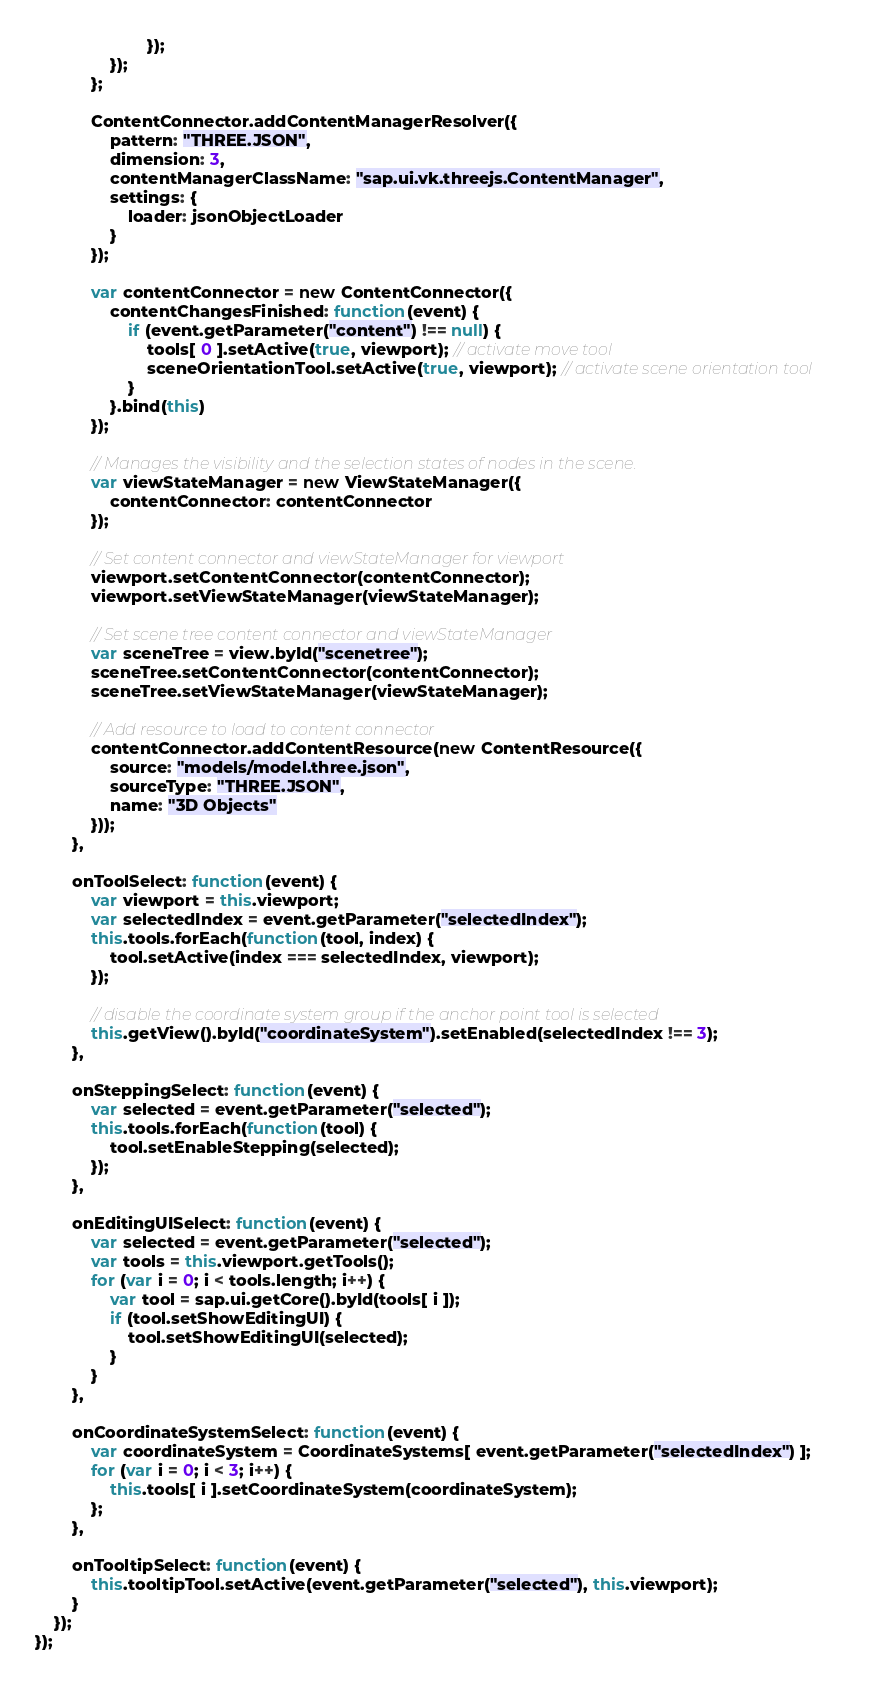<code> <loc_0><loc_0><loc_500><loc_500><_JavaScript_>						});
				});
			};

			ContentConnector.addContentManagerResolver({
				pattern: "THREE.JSON",
				dimension: 3,
				contentManagerClassName: "sap.ui.vk.threejs.ContentManager",
				settings: {
					loader: jsonObjectLoader
				}
			});

			var contentConnector = new ContentConnector({
				contentChangesFinished: function(event) {
					if (event.getParameter("content") !== null) {
						tools[ 0 ].setActive(true, viewport); // activate move tool
						sceneOrientationTool.setActive(true, viewport); // activate scene orientation tool
					}
				}.bind(this)
			});

			// Manages the visibility and the selection states of nodes in the scene.
			var viewStateManager = new ViewStateManager({
				contentConnector: contentConnector
			});

			// Set content connector and viewStateManager for viewport
			viewport.setContentConnector(contentConnector);
			viewport.setViewStateManager(viewStateManager);

			// Set scene tree content connector and viewStateManager
			var sceneTree = view.byId("scenetree");
			sceneTree.setContentConnector(contentConnector);
			sceneTree.setViewStateManager(viewStateManager);

			// Add resource to load to content connector
			contentConnector.addContentResource(new ContentResource({
				source: "models/model.three.json",
				sourceType: "THREE.JSON",
				name: "3D Objects"
			}));
		},

		onToolSelect: function(event) {
			var viewport = this.viewport;
			var selectedIndex = event.getParameter("selectedIndex");
			this.tools.forEach(function(tool, index) {
				tool.setActive(index === selectedIndex, viewport);
			});

			// disable the coordinate system group if the anchor point tool is selected
			this.getView().byId("coordinateSystem").setEnabled(selectedIndex !== 3);
		},

		onSteppingSelect: function(event) {
			var selected = event.getParameter("selected");
			this.tools.forEach(function(tool) {
				tool.setEnableStepping(selected);
			});
		},

		onEditingUISelect: function(event) {
			var selected = event.getParameter("selected");
			var tools = this.viewport.getTools();
			for (var i = 0; i < tools.length; i++) {
				var tool = sap.ui.getCore().byId(tools[ i ]);
				if (tool.setShowEditingUI) {
					tool.setShowEditingUI(selected);
				}
			}
		},

		onCoordinateSystemSelect: function(event) {
			var coordinateSystem = CoordinateSystems[ event.getParameter("selectedIndex") ];
			for (var i = 0; i < 3; i++) {
				this.tools[ i ].setCoordinateSystem(coordinateSystem);
			};
		},

		onTooltipSelect: function(event) {
			this.tooltipTool.setActive(event.getParameter("selected"), this.viewport);
		}
	});
});</code> 